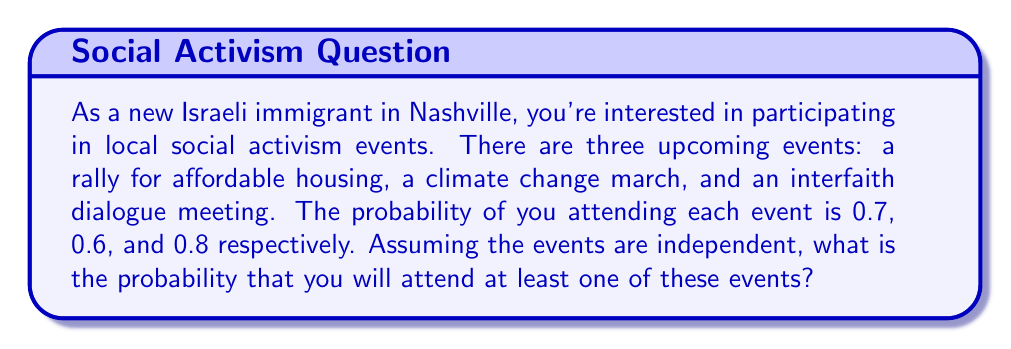What is the answer to this math problem? Let's approach this step-by-step:

1) First, let's define our events:
   A: Attending the affordable housing rally
   B: Attending the climate change march
   C: Attending the interfaith dialogue meeting

2) We're given the following probabilities:
   $P(A) = 0.7$
   $P(B) = 0.6$
   $P(C) = 0.8$

3) To find the probability of attending at least one event, it's easier to calculate the probability of not attending any event and then subtract this from 1.

4) The probability of not attending an event is the complement of attending:
   $P(\text{not A}) = 1 - P(A) = 1 - 0.7 = 0.3$
   $P(\text{not B}) = 1 - P(B) = 1 - 0.6 = 0.4$
   $P(\text{not C}) = 1 - P(C) = 1 - 0.8 = 0.2$

5) Since the events are independent, the probability of not attending any event is the product of the probabilities of not attending each individual event:

   $P(\text{not A and not B and not C}) = P(\text{not A}) \times P(\text{not B}) \times P(\text{not C})$
   $= 0.3 \times 0.4 \times 0.2 = 0.024$

6) Therefore, the probability of attending at least one event is:

   $P(\text{at least one}) = 1 - P(\text{none}) = 1 - 0.024 = 0.976$
Answer: The probability of attending at least one of these social activism events is 0.976 or 97.6%. 